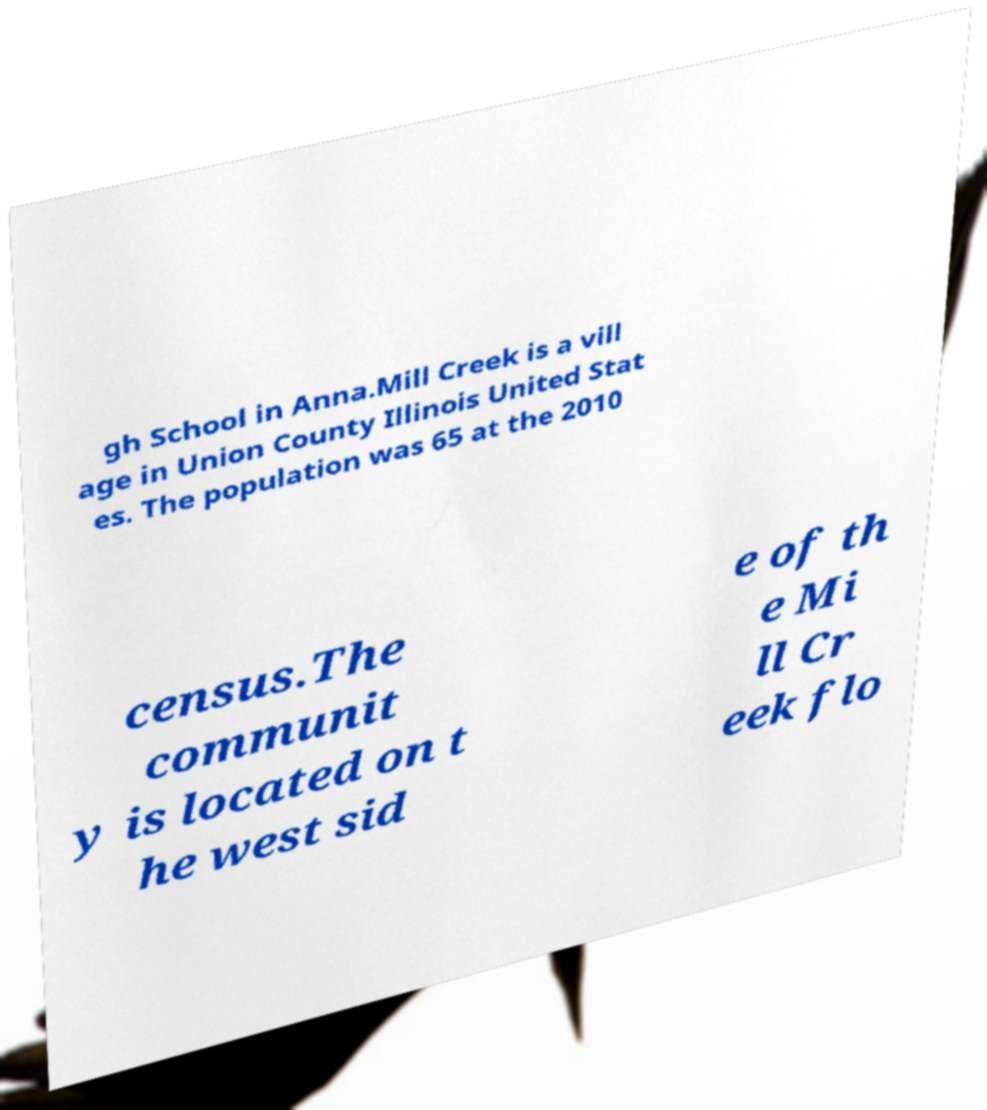Please identify and transcribe the text found in this image. gh School in Anna.Mill Creek is a vill age in Union County Illinois United Stat es. The population was 65 at the 2010 census.The communit y is located on t he west sid e of th e Mi ll Cr eek flo 